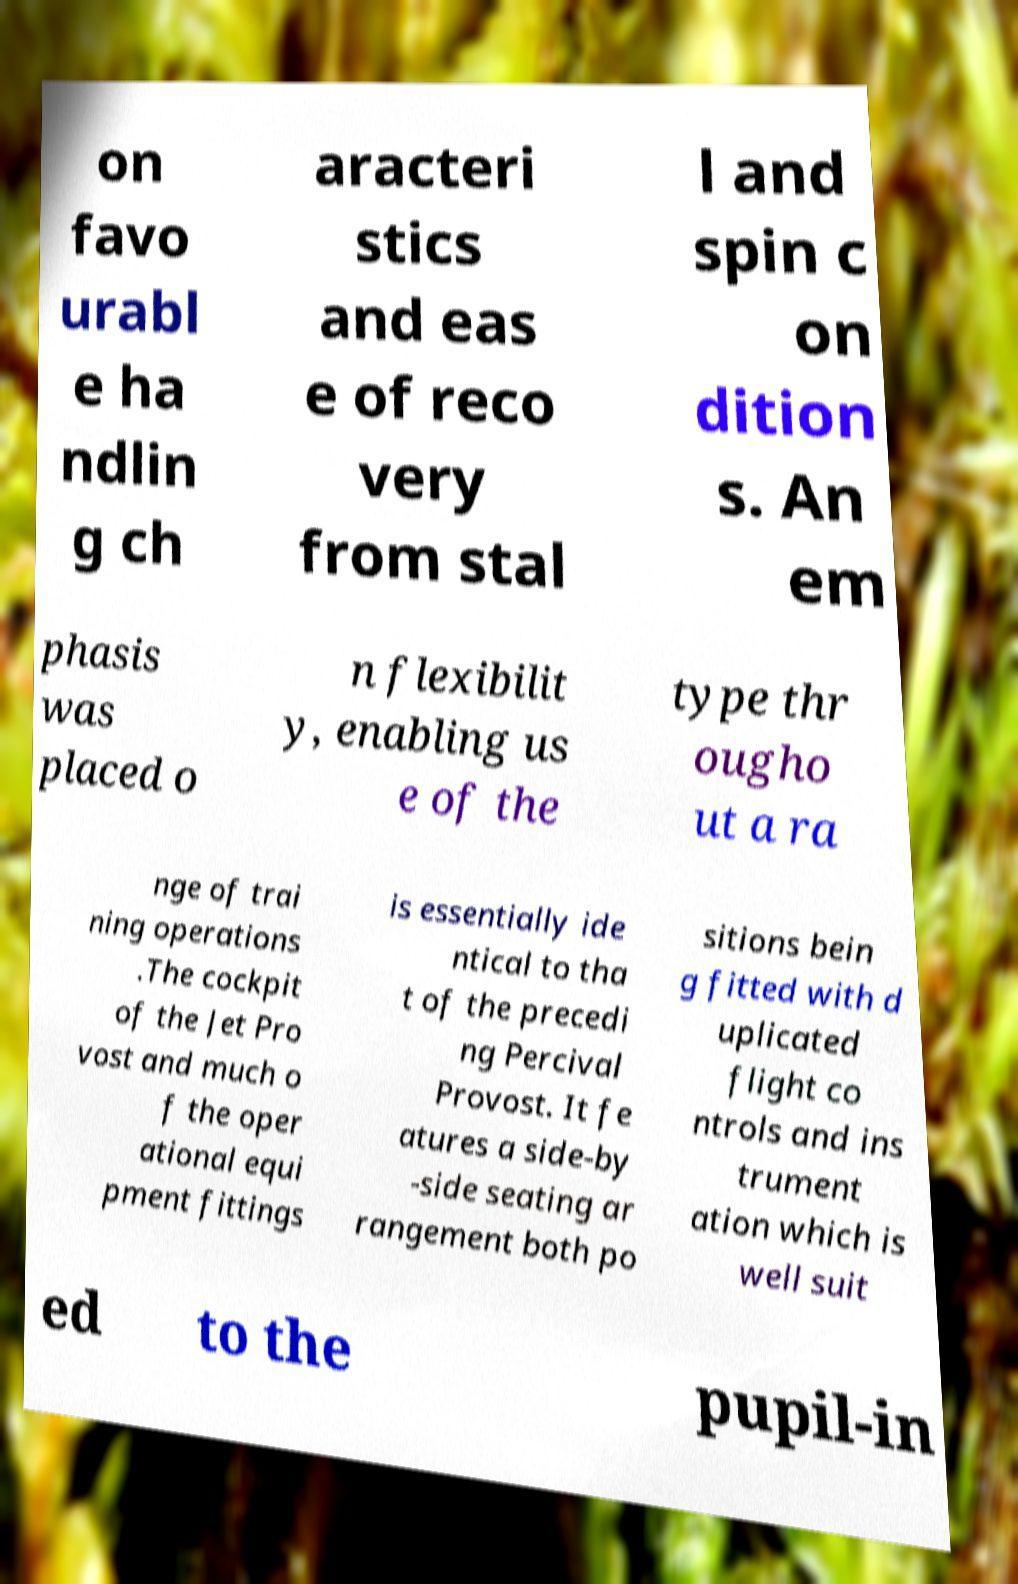Can you accurately transcribe the text from the provided image for me? on favo urabl e ha ndlin g ch aracteri stics and eas e of reco very from stal l and spin c on dition s. An em phasis was placed o n flexibilit y, enabling us e of the type thr ougho ut a ra nge of trai ning operations .The cockpit of the Jet Pro vost and much o f the oper ational equi pment fittings is essentially ide ntical to tha t of the precedi ng Percival Provost. It fe atures a side-by -side seating ar rangement both po sitions bein g fitted with d uplicated flight co ntrols and ins trument ation which is well suit ed to the pupil-in 